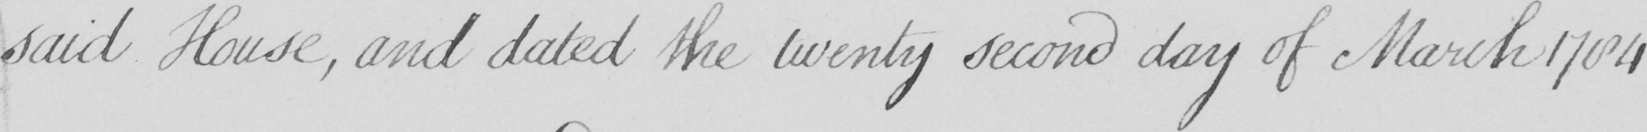Can you tell me what this handwritten text says? said House , and dated the twenty second day of March 1784 